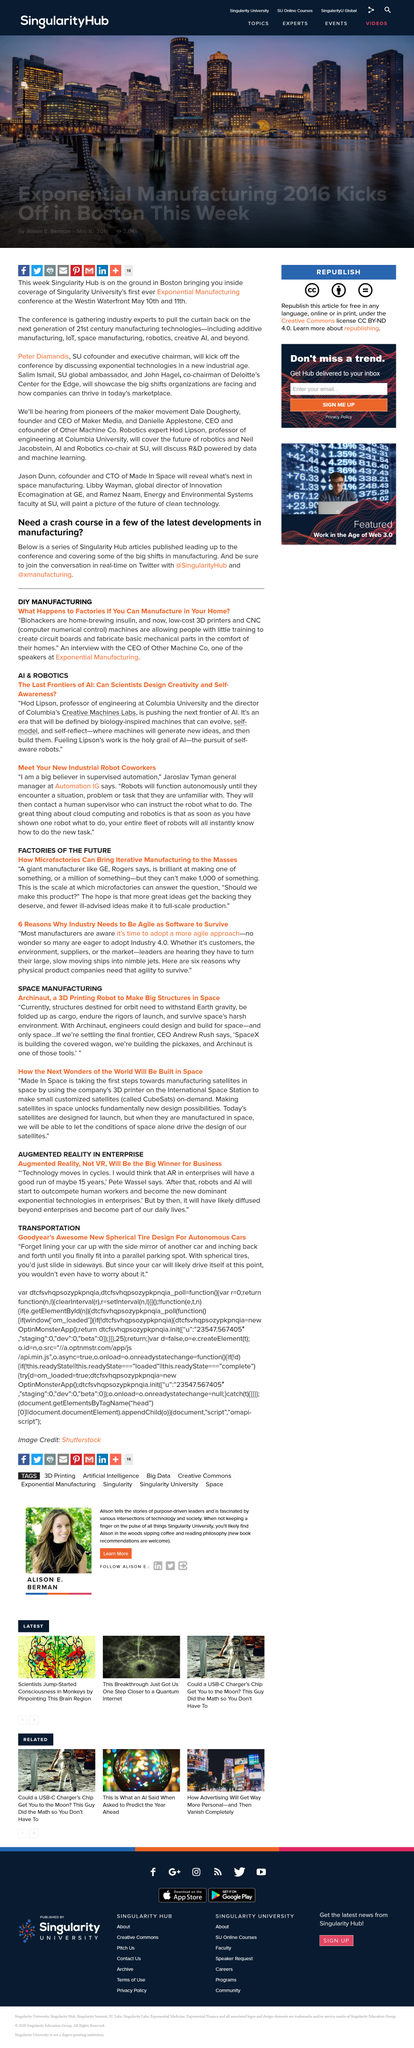Give some essential details in this illustration. Jaroslav Tyman, an individual affiliated with Automation IG, believes that it is possible to have supervised robot coworkers. According to Jaroslav Tyman, robots can function autonomously when working on tasks they are familiar with. The general manager at Automation IG is Jaroslav Tyman. 